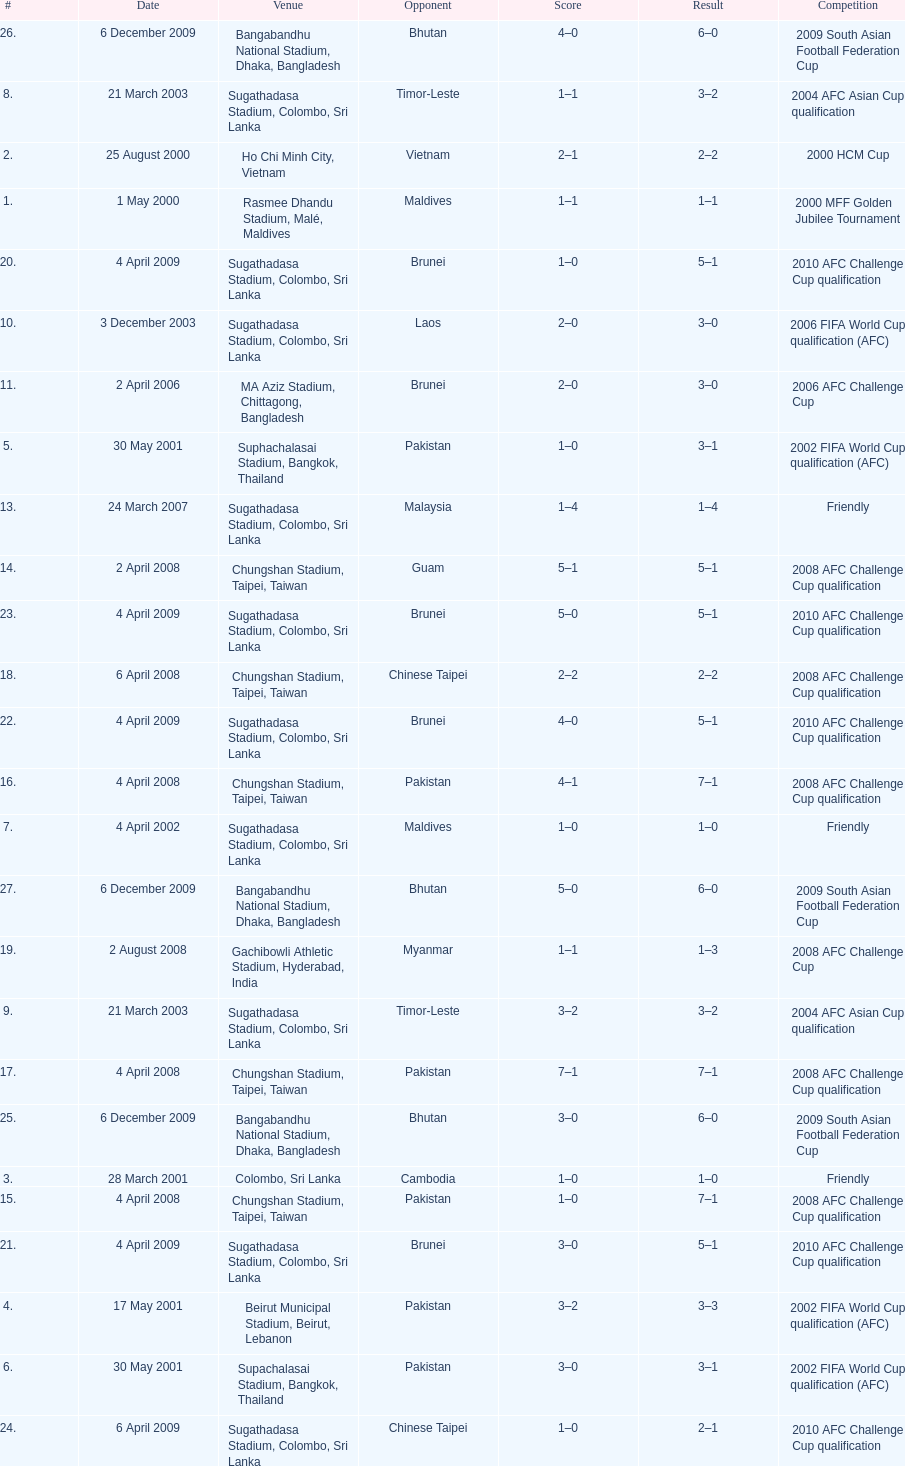Were more competitions played in april or december? April. 